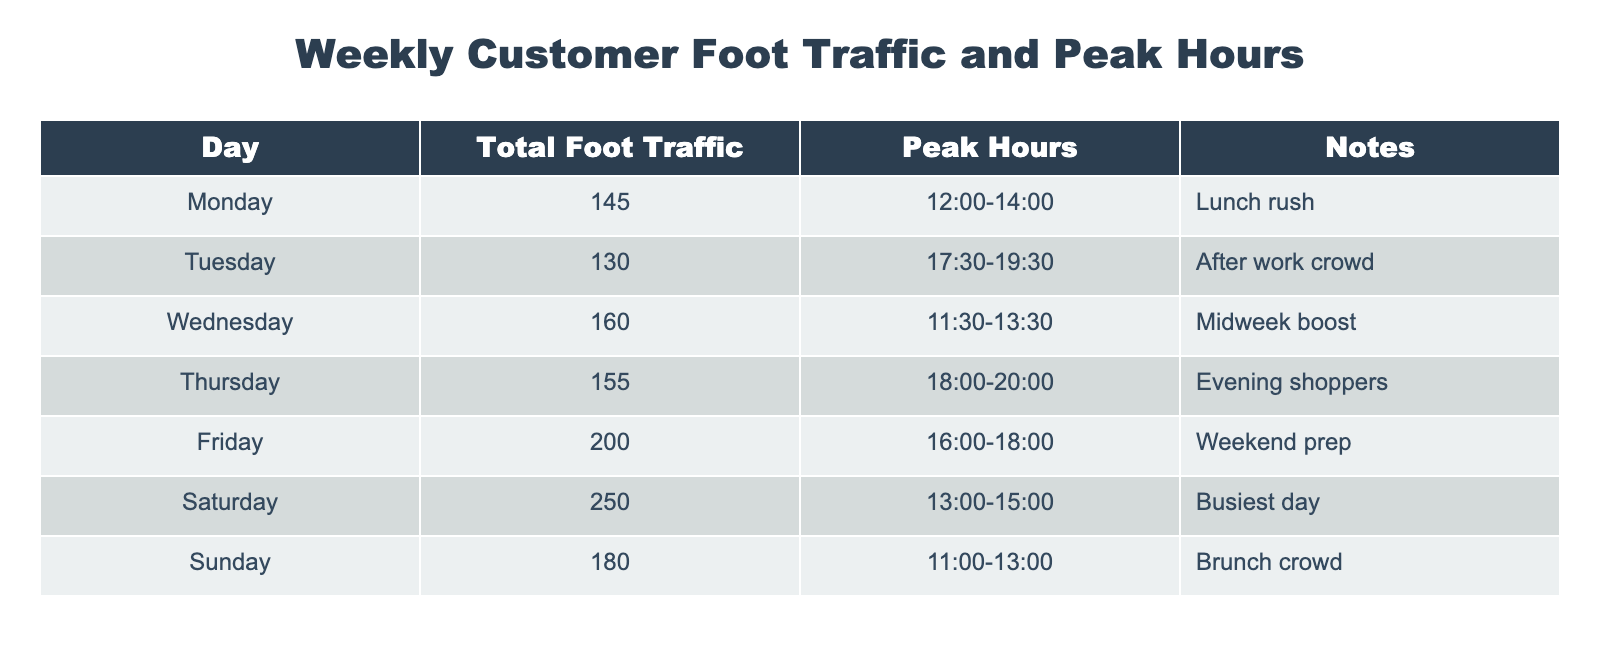What is the total foot traffic on Friday? The foot traffic for Friday is explicitly mentioned in the table under the "Total Foot Traffic" column. It states 200.
Answer: 200 Which day has the highest foot traffic? By comparing the values in the "Total Foot Traffic" column, Saturday has the highest value at 250.
Answer: Saturday What are the peak hours on Wednesday? The peak hours for Wednesday are listed in the "Peak Hours" column, which shows the time as 11:30 to 13:30.
Answer: 11:30-13:30 Is there a day with foot traffic greater than 150? By looking at the "Total Foot Traffic" column, both Saturday (250) and Friday (200) exceed 150, thus the answer is yes.
Answer: Yes What is the average foot traffic for the week? To find the average, sum the total foot traffic values (145 + 130 + 160 + 155 + 200 + 250 + 180 = 1,220) and divide by the number of days (7). The average is 1,220 / 7, which equals approximately 174.29.
Answer: 174.29 What is the difference in foot traffic between Saturday and Tuesday? The foot traffic for Saturday is 250, and for Tuesday, it is 130. The difference is 250 - 130 = 120.
Answer: 120 How many days have peak hours that start after 17:00? The days with peak hours starting after 17:00 are Tuesday (17:30), Thursday (18:00), and Friday (16:00) counts as one as it starts before but ends after. Thus, a total of 3 days meet this criterion.
Answer: 3 What is the total foot traffic for the days with evening peak hours? The days with evening peak hours (Thursday and Friday) have foot traffic values of 155 and 200, respectively. Adding these together gives 155 + 200 = 355 for the total.
Answer: 355 Do more customers visit during lunch hours compared to brunch hours? Lunch hours (Monday, Wednesday, Saturday) total 145 + 160 + 250 = 555. Brunch hours (Sunday) total 180. Since 555 is greater than 180, it confirms that lunchtime sees more customers.
Answer: Yes 